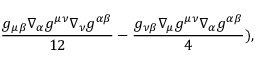<formula> <loc_0><loc_0><loc_500><loc_500>\frac { g _ { \mu \beta } \nabla _ { \alpha } g ^ { \mu \nu } \nabla _ { \nu } g ^ { \alpha \beta } } { 1 2 } - \frac { g _ { \nu \beta } \nabla _ { \mu } g ^ { \mu \nu } \nabla _ { \alpha } g ^ { \alpha \beta } } { 4 } ) ,</formula> 